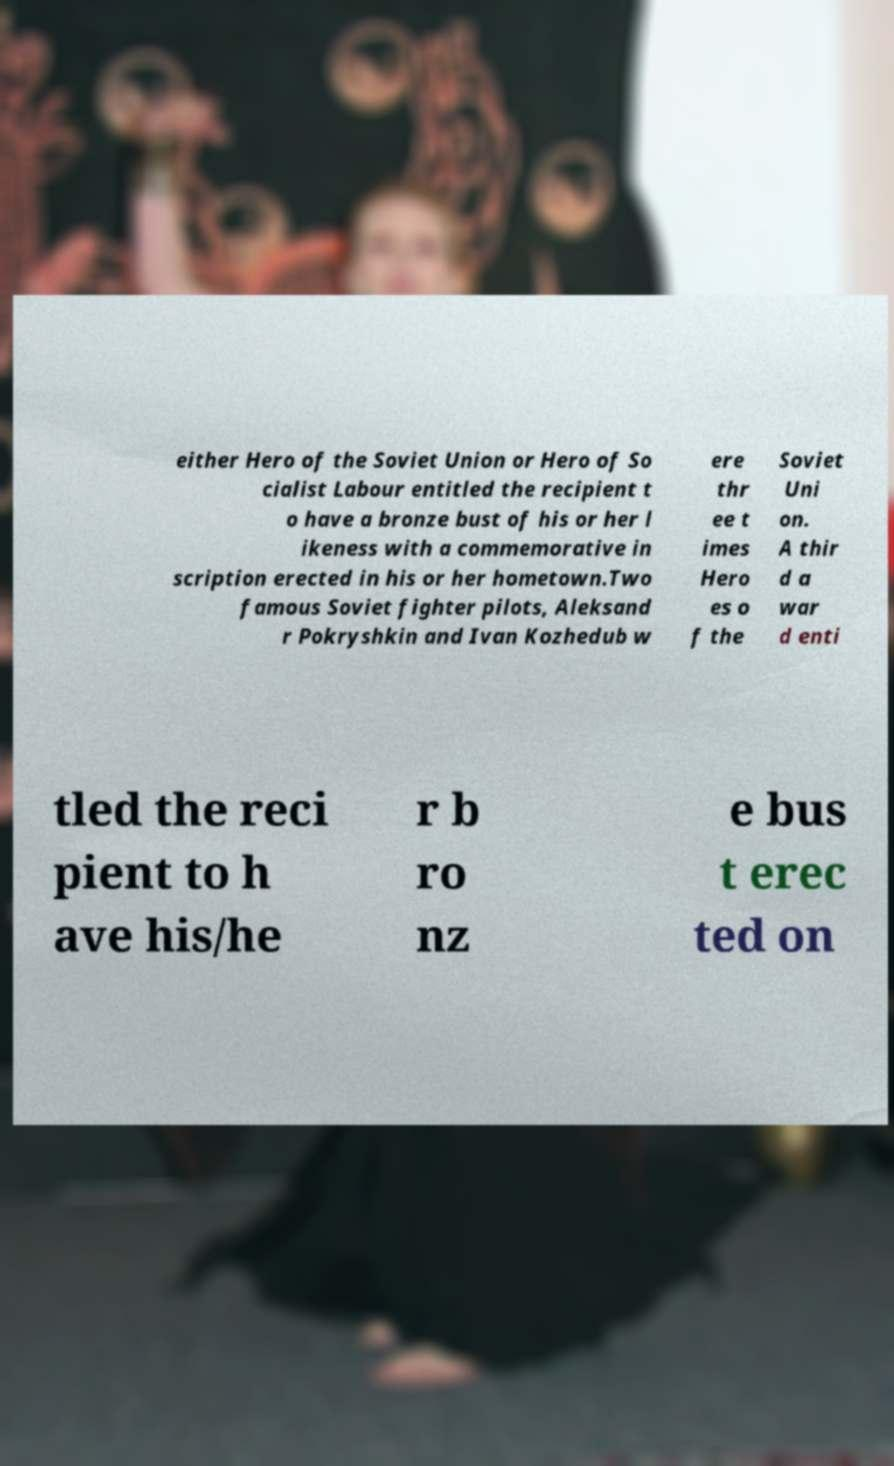What messages or text are displayed in this image? I need them in a readable, typed format. either Hero of the Soviet Union or Hero of So cialist Labour entitled the recipient t o have a bronze bust of his or her l ikeness with a commemorative in scription erected in his or her hometown.Two famous Soviet fighter pilots, Aleksand r Pokryshkin and Ivan Kozhedub w ere thr ee t imes Hero es o f the Soviet Uni on. A thir d a war d enti tled the reci pient to h ave his/he r b ro nz e bus t erec ted on 